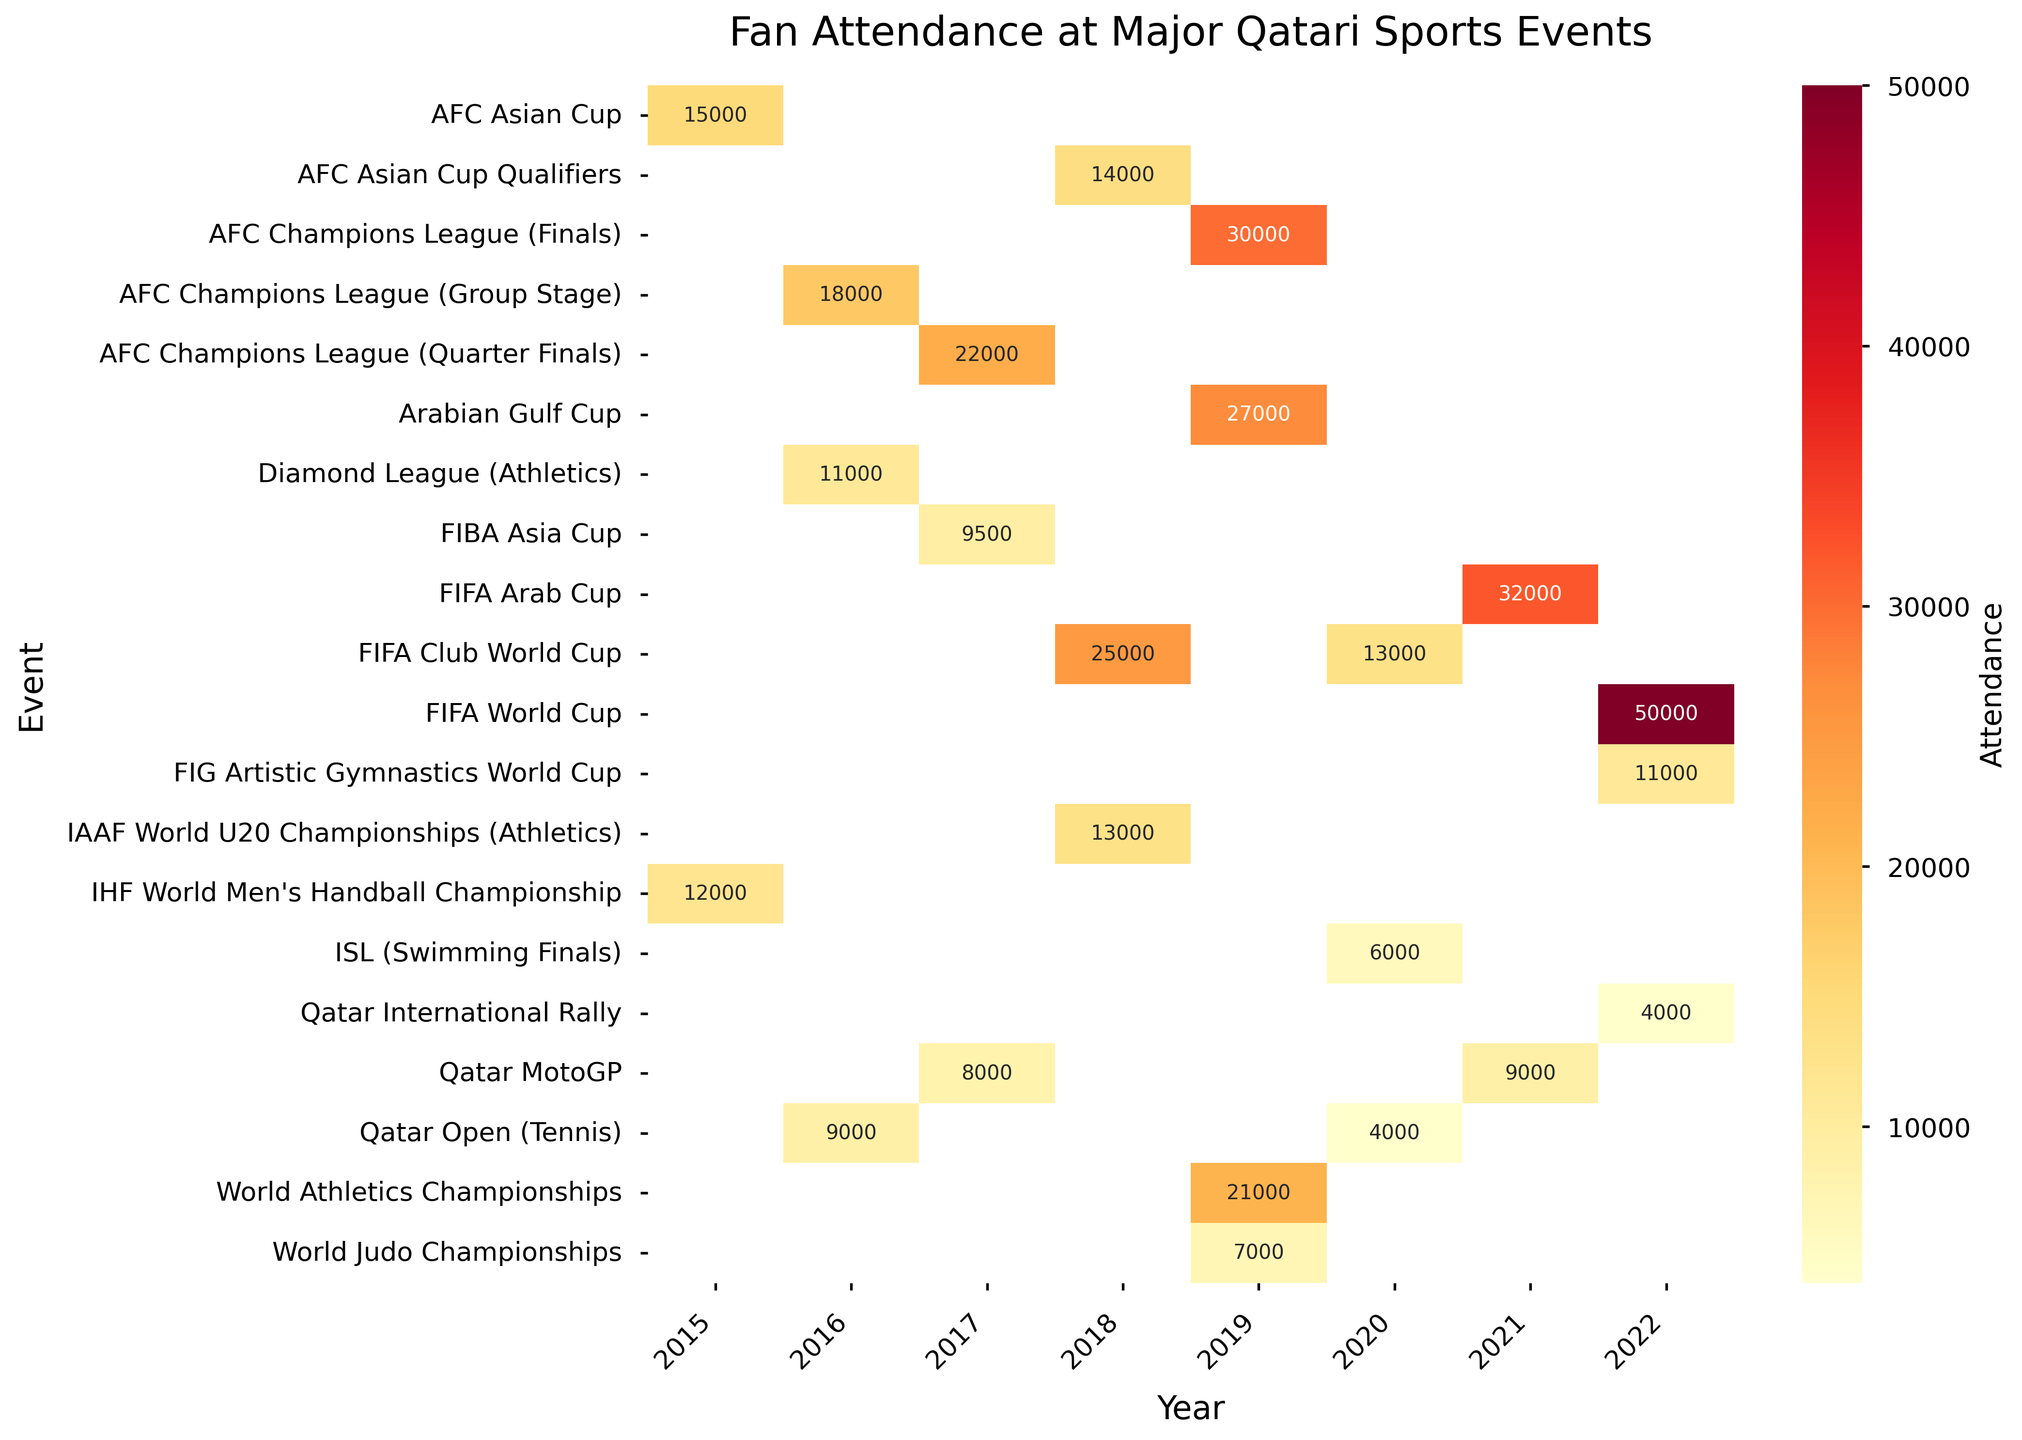How many events were held in Doha in 2022? Look at the heatmap and identify the events listed under 2022. Then, count how many events have their location marked as "Doha".
Answer: 4 Which event had the highest fan attendance in 2018? Check the values in the 2018 column and compare them to identify the highest number.
Answer: FIFA Club World Cup What is the difference in fan attendance between the AFC Champions League Finals in 2019 and the FIFA Arab Cup in 2021? Locate these two events in the heatmap. For the AFC Champions League Finals in 2019, the attendance is 30,000, and for the FIFA Arab Cup in 2021, the attendance is 32,000. The difference is 32,000 - 30,000.
Answer: 2,000 Which year had the lowest attendance for the Qatar Open (Tennis)? Identify the Qatar Open (Tennis) row and observe the values across different years. The lowest value among them indicates the lowest attendance year.
Answer: 2020 What is the average attendance of the AFC Asian Cup across all years? Find the attendance values for the AFC Asian Cup in each year it occurred (2015 and 2018). Calculate the average: (15,000 + 14,000) / 2.
Answer: 14,500 Compare the fan attendance of the IHF World Men's Handball Championship in 2015 and the FIG Artistic Gymnastics World Cup in 2022. Which had higher attendance? Locate both events and compare their attendance values: IHF World Men's Handball Championship in 2015 (12,000) and FIG Artistic Gymnastics World Cup in 2022 (11,000).
Answer: IHF World Men's Handball Championship Which location hosted the most events over the recorded years? To determine which location hosted the most events, count the number of events listed for each location across different years.
Answer: Doha Among the years recorded, which year saw the highest overall attendance in major sports events? Sum the attendance figures for all events in each year and compare the totals to determine the highest overall attendance year.
Answer: 2022 How much higher was the attendance at the FIFA World Cup in 2022 compared to the Qatar Open (Tennis) in 2016? Find the attendance values for both events: FIFA World Cup in 2022 (50,000) and Qatar Open (Tennis) in 2016 (9,000). Calculate the difference: 50,000 - 9,000.
Answer: 41,000 What is the total attendance for all the Qatar MotoGP events listed? Identify the attendance values for the Qatar MotoGP in 2017 and 2021. Sum these values: 8,000 + 9,000.
Answer: 17,000 